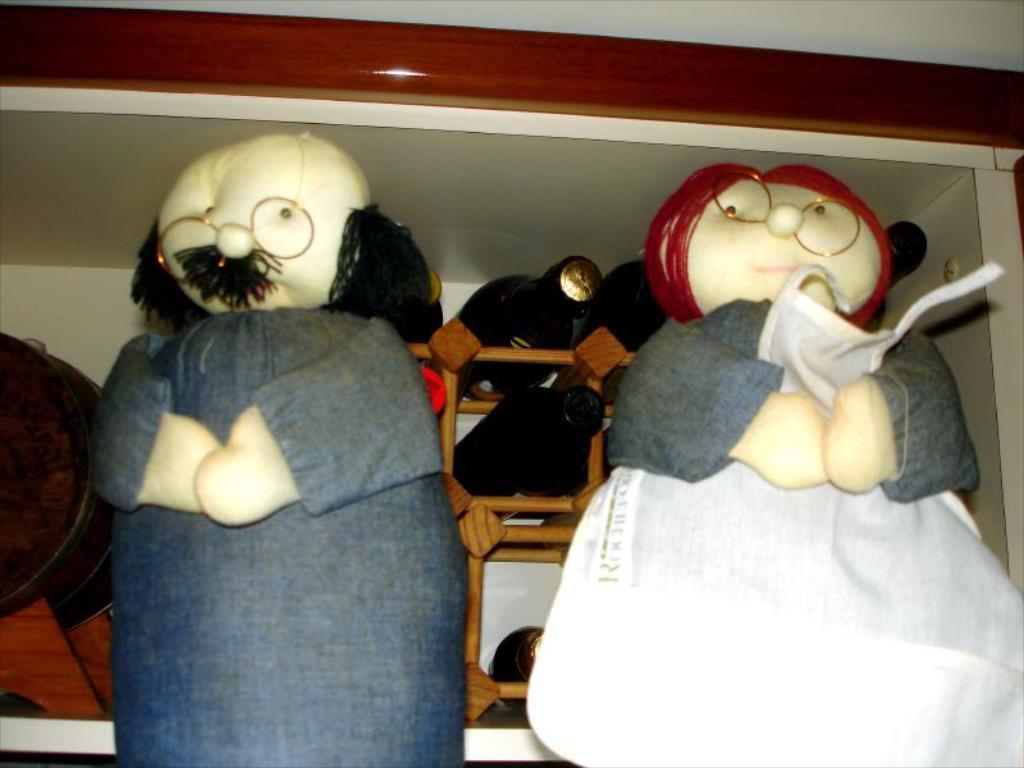Describe this image in one or two sentences. In this image in the foreground there are two toys, and in the background there is a shelf. And in that shelf there are some bottles, basket and some objects, and in the background there is a wall. 